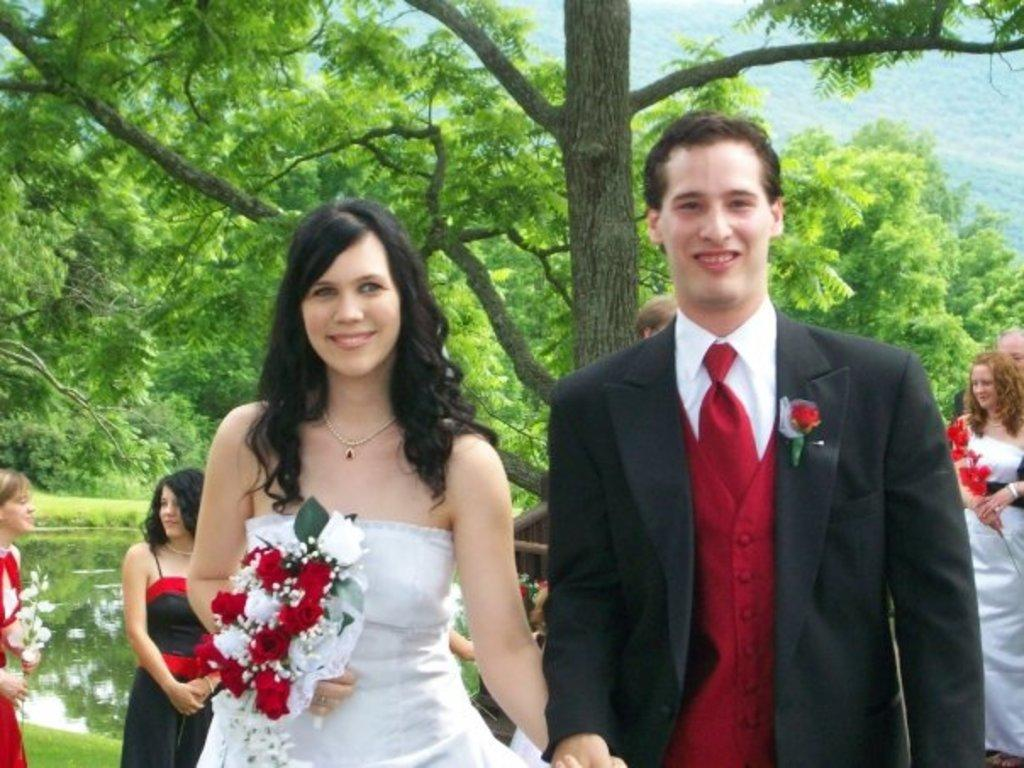What are the people in the image doing? The people in the image are standing on the ground. What are some of the women holding in their hands? Some women are holding flowers in their hands. What can be seen in the background of the image? There is water and a group of trees visible in the background of the image. How does the group of people sort the flowers in the image? There is no indication in the image that the group of people is sorting flowers. 